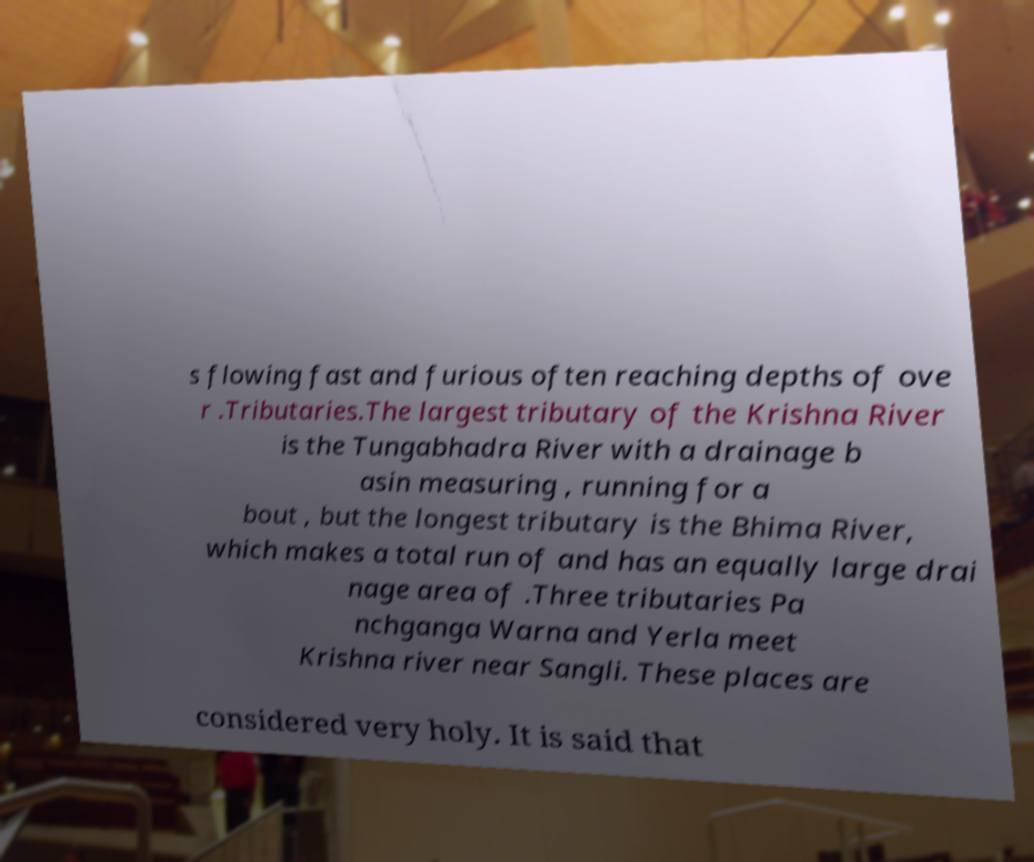I need the written content from this picture converted into text. Can you do that? s flowing fast and furious often reaching depths of ove r .Tributaries.The largest tributary of the Krishna River is the Tungabhadra River with a drainage b asin measuring , running for a bout , but the longest tributary is the Bhima River, which makes a total run of and has an equally large drai nage area of .Three tributaries Pa nchganga Warna and Yerla meet Krishna river near Sangli. These places are considered very holy. It is said that 